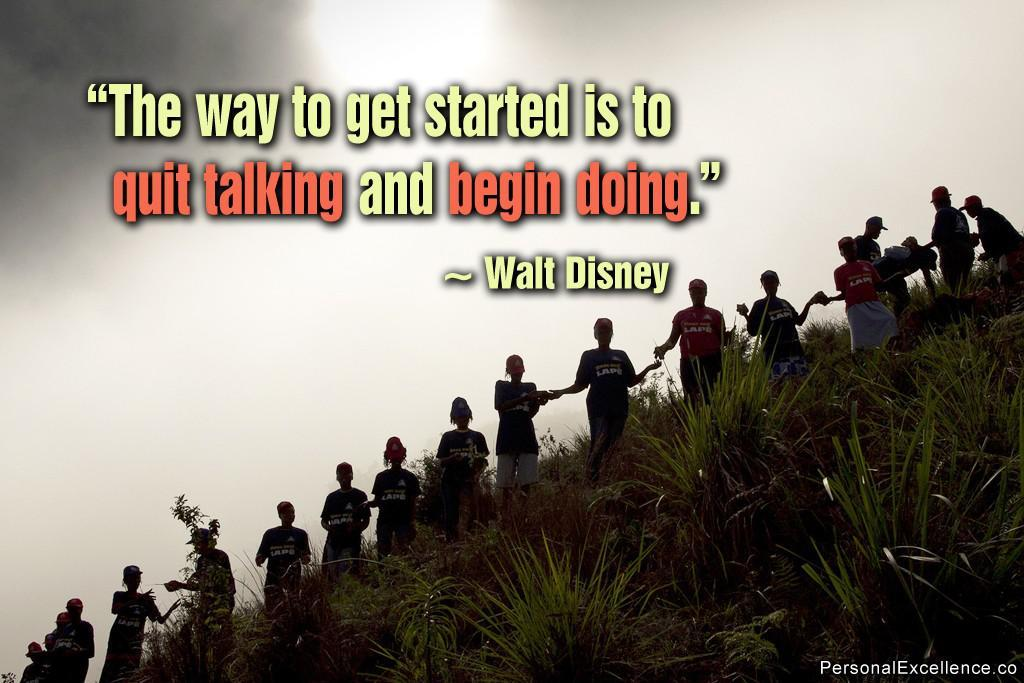Provide a one-sentence caption for the provided image. The picture of random people on a hill features a quote from Walt Disney. 